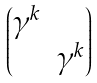Convert formula to latex. <formula><loc_0><loc_0><loc_500><loc_500>\begin{pmatrix} \gamma ^ { k } & \\ & \gamma ^ { k } \\ \end{pmatrix}</formula> 